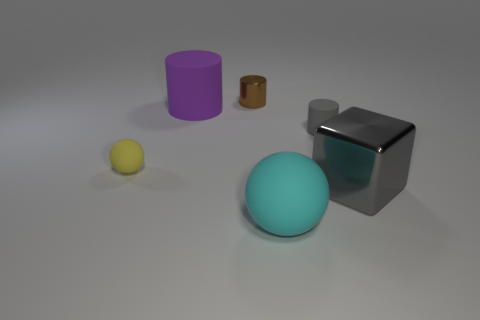Add 4 tiny brown shiny cylinders. How many objects exist? 10 Subtract all cubes. How many objects are left? 5 Add 1 tiny matte cylinders. How many tiny matte cylinders are left? 2 Add 5 yellow rubber spheres. How many yellow rubber spheres exist? 6 Subtract 0 blue spheres. How many objects are left? 6 Subtract all large green shiny cylinders. Subtract all rubber things. How many objects are left? 2 